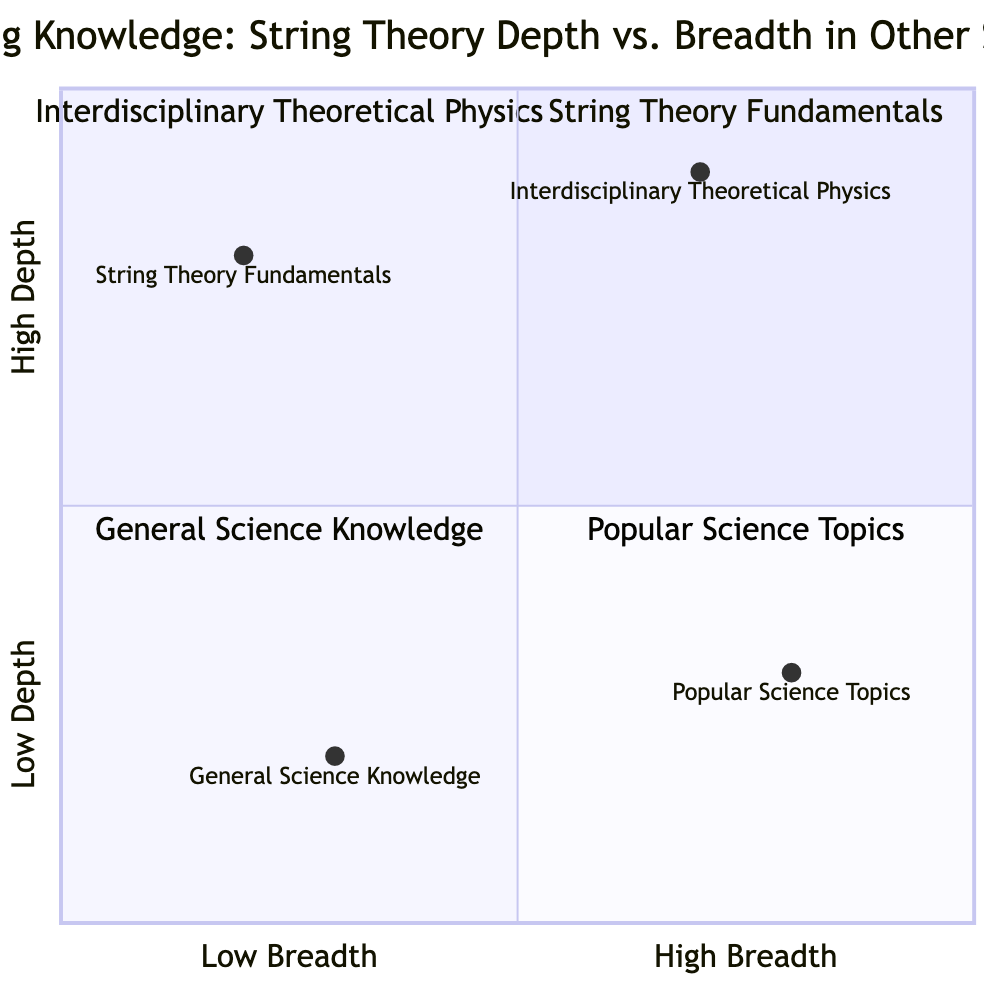What is found in the "High Depth, Low Breadth" quadrant? The "High Depth, Low Breadth" quadrant contains "String Theory Fundamentals." This is directly stated in the details of the quadrant content.
Answer: String Theory Fundamentals Which quadrant contains the term "Interdisciplinary Theoretical Physics"? "Interdisciplinary Theoretical Physics" is located in the "High Depth, High Breadth" quadrant. This is found from the specific description of that quadrant.
Answer: High Depth, High Breadth How many quadrants are represented in this chart? The chart contains four quadrants: High Depth, Low Breadth; High Depth, High Breadth; Low Depth, Low Breadth; and Low Depth, High Breadth. Counting these quadrants yields a total of four.
Answer: 4 What is the primary focus of "Popular Science Topics"? "Popular Science Topics" focuses on reading habits of science magazines and books, highlighting familiar recent scientific discoveries which is explained in the details of this quadrant.
Answer: Reading habit of science magazines Which quadrant has both low depth and low breadth? The quadrant that has both low depth and low breadth is "General Science Knowledge." This is noted under the details for that specific quadrant.
Answer: General Science Knowledge In which quadrant would one find advanced mathematical frameworks related to string theory? Advanced mathematical frameworks related to string theory are found in the "High Depth, Low Breadth" quadrant, specifically listed as "String Theory Fundamentals."
Answer: String Theory Fundamentals Which provides more insight into various scientific disciplines: "Interdisciplinary Theoretical Physics" or "General Science Knowledge"? "Interdisciplinary Theoretical Physics" provides more insight because it combines string theory with elements from other domains such as quantum mechanics and cosmology, showcasing higher breadth and depth compared to "General Science Knowledge," which is more basic.
Answer: Interdisciplinary Theoretical Physics What aspect is emphasized in the "Low Depth, High Breadth" quadrant? The "Low Depth, High Breadth" quadrant emphasizes familiarity with recent scientific discoveries and popular science literature, which is detailed in the descriptions there.
Answer: Familiarity with recent scientific discoveries Which quadrant would be more suitable for someone with a limited understanding of science? "General Science Knowledge," which is in the Low Depth, Low Breadth quadrant, would be more suitable for someone with a limited understanding of science as it contains only basic scientific principles.
Answer: General Science Knowledge 